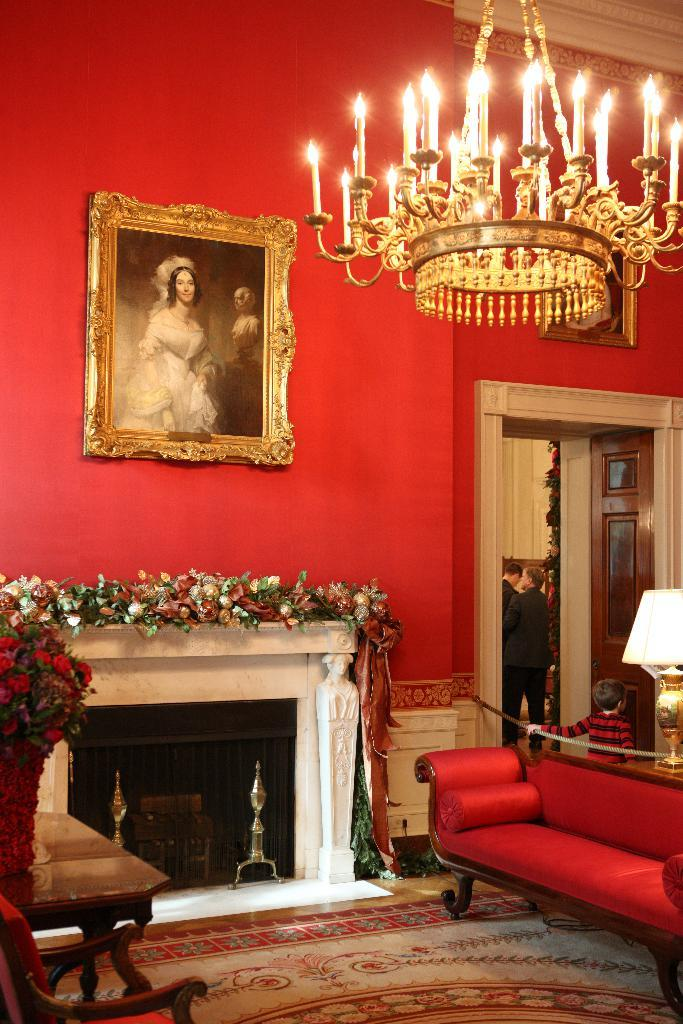What is the setting of the image? The image is inside a room. What type of furniture is present in the room? There is a couch in the room. Can you describe the decoration on the wall? There is a picture of a woman on a red color wall. What type of lighting is present in the room? There are candles in the room. Are there any people in the room? Yes, there are persons standing in the room. What type of decorative elements can be seen in the room? There are flowers in the room. How much payment is required to enter the room in the image? There is no mention of payment or any entrance fee in the image. Can you see a snail crawling on the couch in the image? There is no snail present in the image. 